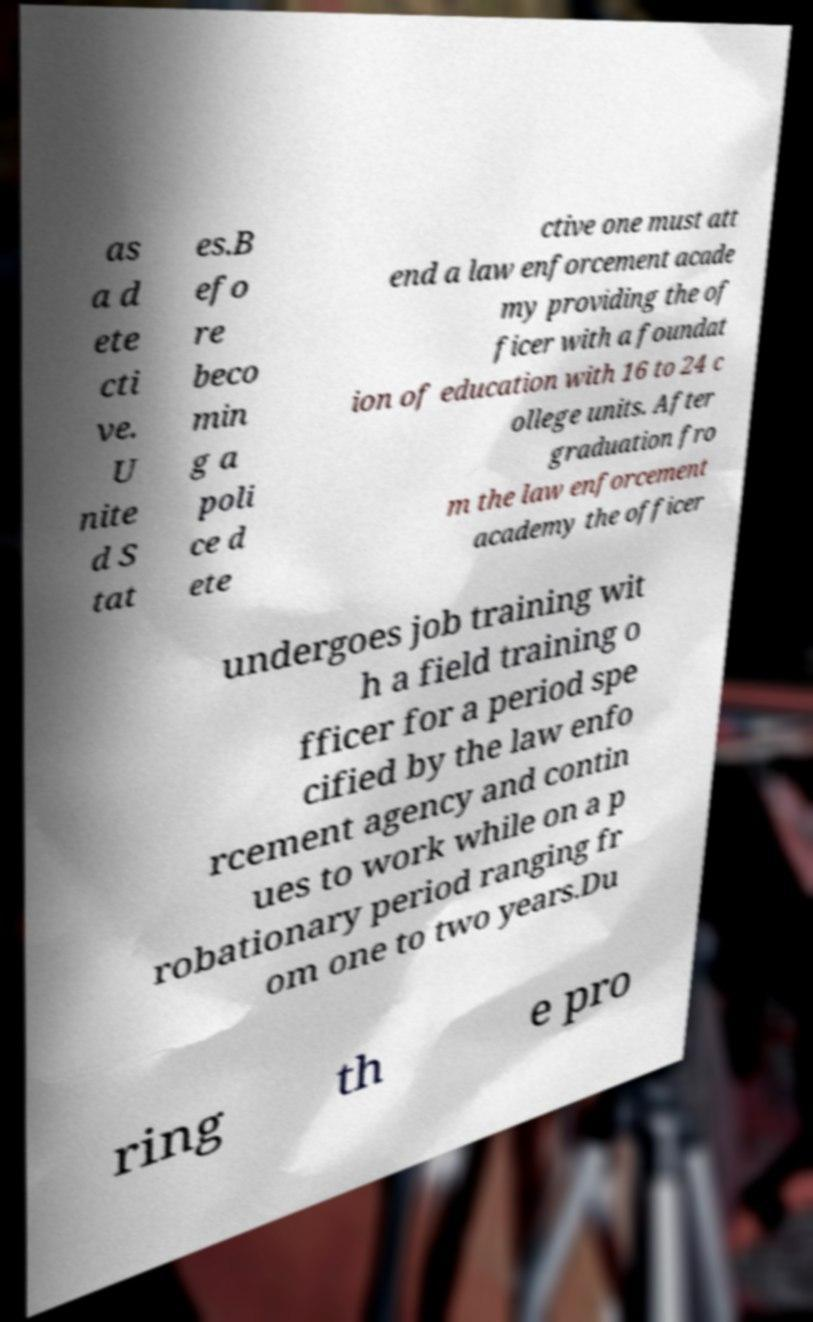Could you assist in decoding the text presented in this image and type it out clearly? as a d ete cti ve. U nite d S tat es.B efo re beco min g a poli ce d ete ctive one must att end a law enforcement acade my providing the of ficer with a foundat ion of education with 16 to 24 c ollege units. After graduation fro m the law enforcement academy the officer undergoes job training wit h a field training o fficer for a period spe cified by the law enfo rcement agency and contin ues to work while on a p robationary period ranging fr om one to two years.Du ring th e pro 